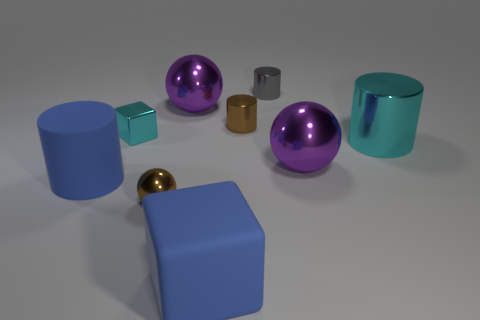Subtract all big cyan cylinders. How many cylinders are left? 3 Add 1 cyan shiny cylinders. How many objects exist? 10 Subtract all brown cylinders. How many cylinders are left? 3 Subtract all spheres. How many objects are left? 6 Subtract 3 balls. How many balls are left? 0 Subtract 0 green cubes. How many objects are left? 9 Subtract all blue balls. Subtract all cyan cylinders. How many balls are left? 3 Subtract all blue blocks. How many cyan cylinders are left? 1 Subtract all large green cylinders. Subtract all big purple metal things. How many objects are left? 7 Add 4 large spheres. How many large spheres are left? 6 